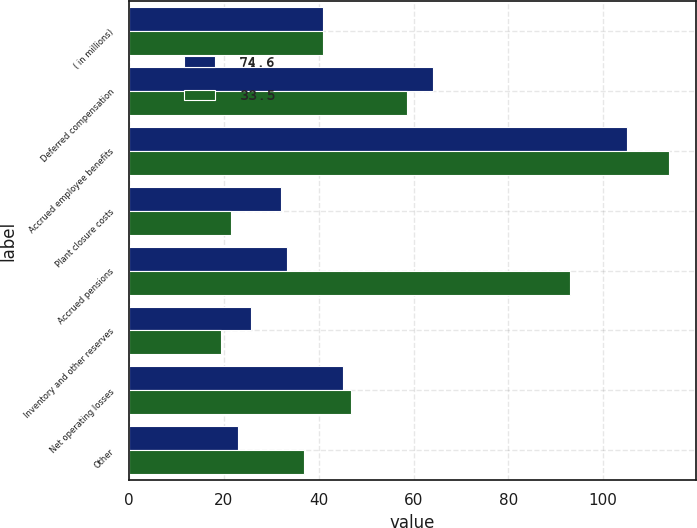Convert chart. <chart><loc_0><loc_0><loc_500><loc_500><stacked_bar_chart><ecel><fcel>( in millions)<fcel>Deferred compensation<fcel>Accrued employee benefits<fcel>Plant closure costs<fcel>Accrued pensions<fcel>Inventory and other reserves<fcel>Net operating losses<fcel>Other<nl><fcel>74.6<fcel>41<fcel>64.2<fcel>105<fcel>32.1<fcel>33.4<fcel>25.8<fcel>45.2<fcel>23<nl><fcel>33.5<fcel>41<fcel>58.7<fcel>113.8<fcel>21.6<fcel>93<fcel>19.4<fcel>46.9<fcel>36.8<nl></chart> 